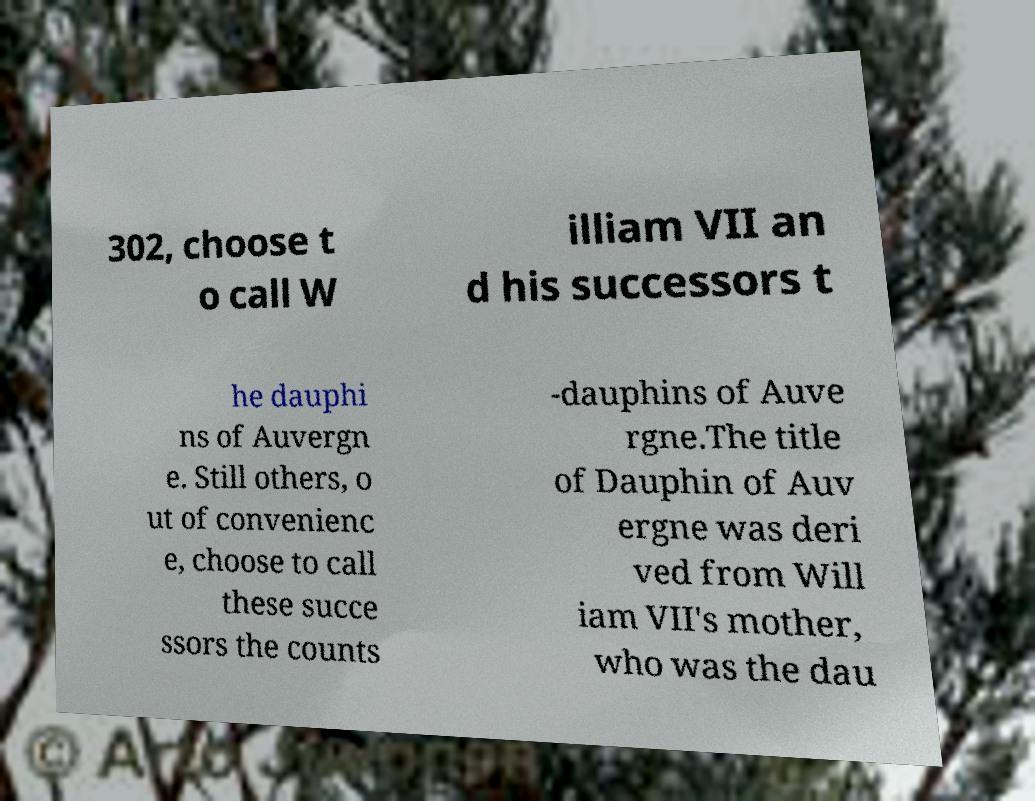Can you accurately transcribe the text from the provided image for me? 302, choose t o call W illiam VII an d his successors t he dauphi ns of Auvergn e. Still others, o ut of convenienc e, choose to call these succe ssors the counts -dauphins of Auve rgne.The title of Dauphin of Auv ergne was deri ved from Will iam VII's mother, who was the dau 